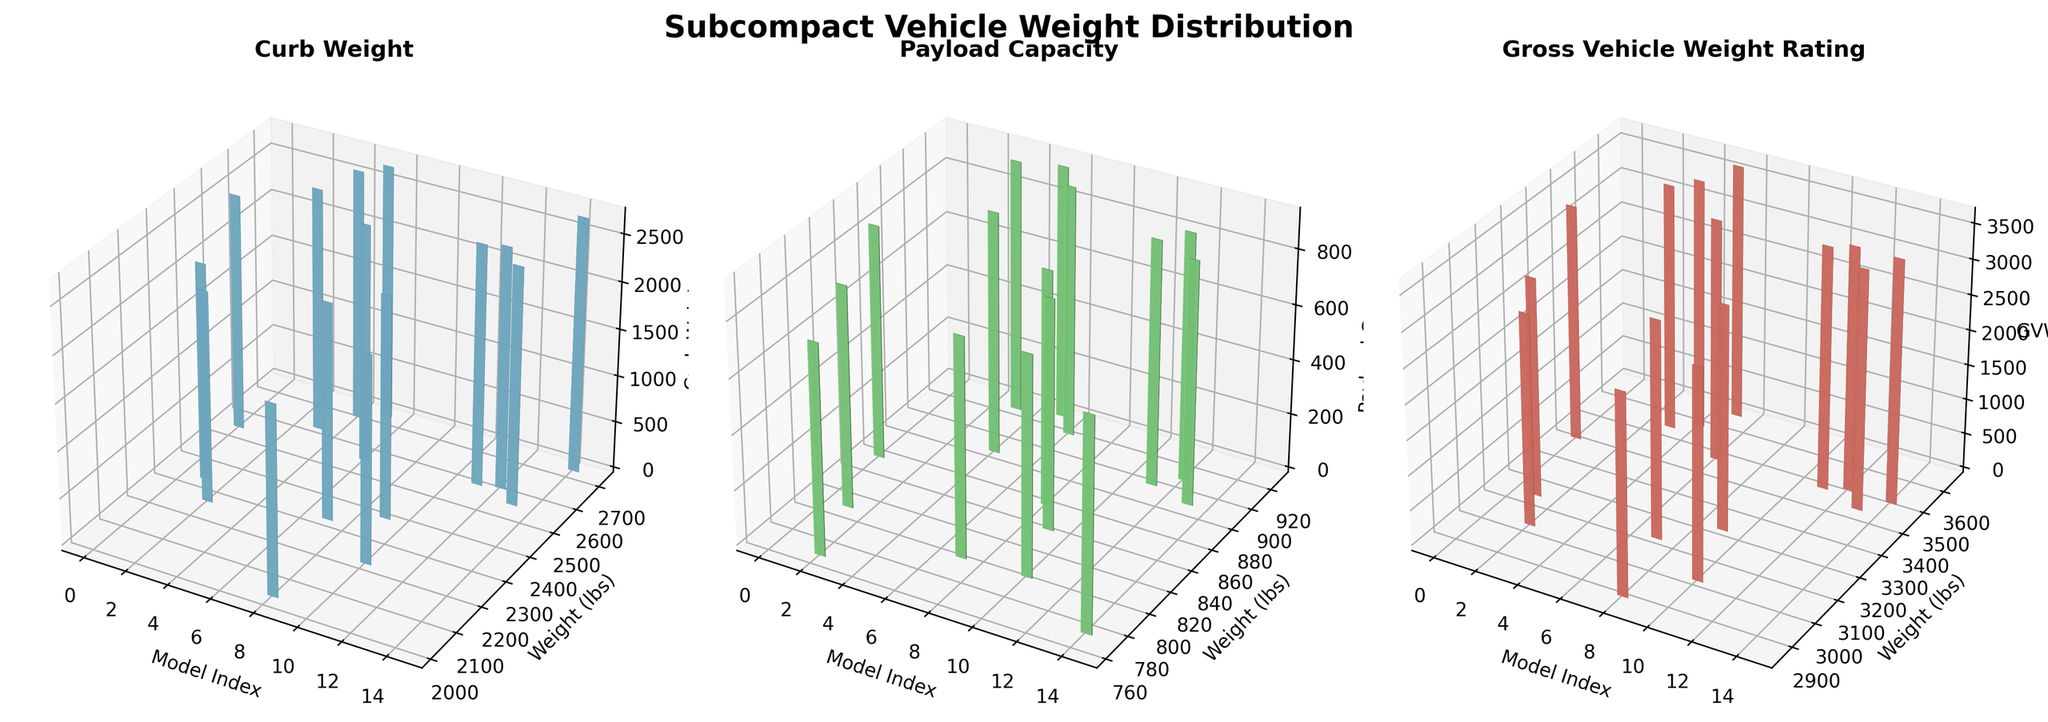Which model has the highest curb weight? Check the tallest bar in the first subplot labeled "Curb Weight" and identify the corresponding model.
Answer: Kia Rio What is the difference in payload capacity between the Nissan Versa and Ford Fiesta? Identify the bars representing Nissan Versa and Ford Fiesta in the second subplot labeled "Payload Capacity" and subtract the values. Nissan Versa: 921, Ford Fiesta: 913. The difference is 921 - 913.
Answer: 8 lbs Which model has the lowest gross vehicle weight rating? Look at the shortest bar in the third subplot labeled "Gross Vehicle Weight Rating" and identify the corresponding model.
Answer: Mitsubishi Mirage What is the average curb weight of the cars? Sum all curb weights from the first subplot and divide by the number of models (15). Total curb weight: 36801, Number of models: 15. The average is 36801 / 15.
Answer: 2453.4 lbs Which model appears consistently in the middle range across all three weight categories? Find the model that falls roughly in the middle of the three subplots. Check visually if any model's bar is consistently in the middle.
Answer: Peugeot 208 How does the payload capacity of the Hyundai Accent compare to the average payload capacity? Calculate the average payload capacity by summing all values from the second subplot and dividing by the number of models (15). Compare Hyundai Accent's payload capacity with the average. Hyundai Accent: 881, Average: (805+764+921+850+805+852+794+764+834+795+892+903+885+769)/15 = 850.
Answer: Higher Which two models have the smallest difference in curb weight? Compare the heights of the bars in the first subplot to find the two closest values, and identify the corresponding models.
Answer: Mazda2 and Toyota Yaris What is the combined gross vehicle weight rating of the Suzuki Swift and Fiat 500? Find the bars representing Suzuki Swift and Fiat 500 in the third subplot, add their gross vehicle weight ratings. Suzuki Swift: 3000, Fiat 500: 3200. Combined: 3000 + 3200.
Answer: 6200 lbs Which model has a higher payload capacity, Mini Cooper or Fiat 500? Compare the bars for Mini Cooper and Fiat 500 in the second subplot. Identify which bar is taller.
Answer: Fiat 500 Is the curb weight of Mitsubishi Mirage more closer to the curb weight of Chevrolet Spark or to that of Mazda2? Check the first subplot and compare the bar heights representing Mitsubishi Mirage, Chevrolet Spark, and Mazda2.
Answer: Chevrolet Spark 